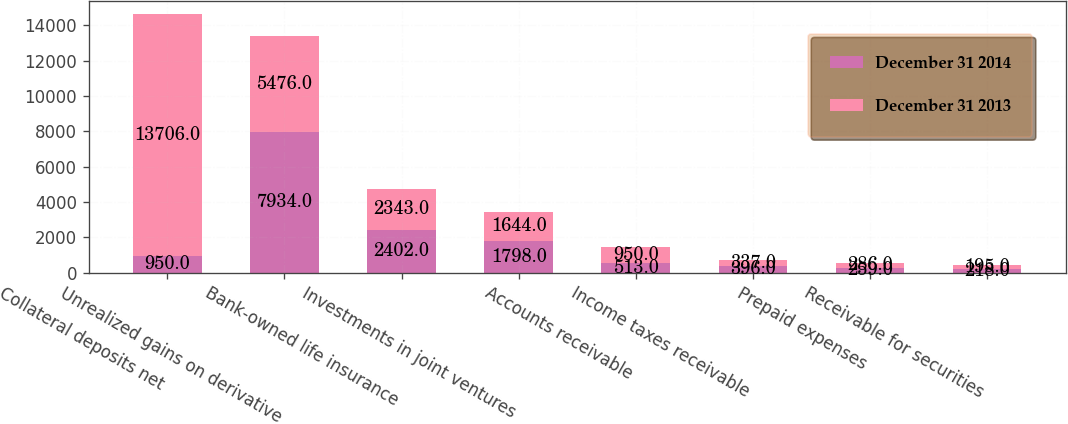Convert chart to OTSL. <chart><loc_0><loc_0><loc_500><loc_500><stacked_bar_chart><ecel><fcel>Collateral deposits net<fcel>Unrealized gains on derivative<fcel>Bank-owned life insurance<fcel>Investments in joint ventures<fcel>Accounts receivable<fcel>Income taxes receivable<fcel>Prepaid expenses<fcel>Receivable for securities<nl><fcel>December 31 2014<fcel>950<fcel>7934<fcel>2402<fcel>1798<fcel>513<fcel>396<fcel>259<fcel>218<nl><fcel>December 31 2013<fcel>13706<fcel>5476<fcel>2343<fcel>1644<fcel>950<fcel>337<fcel>286<fcel>195<nl></chart> 